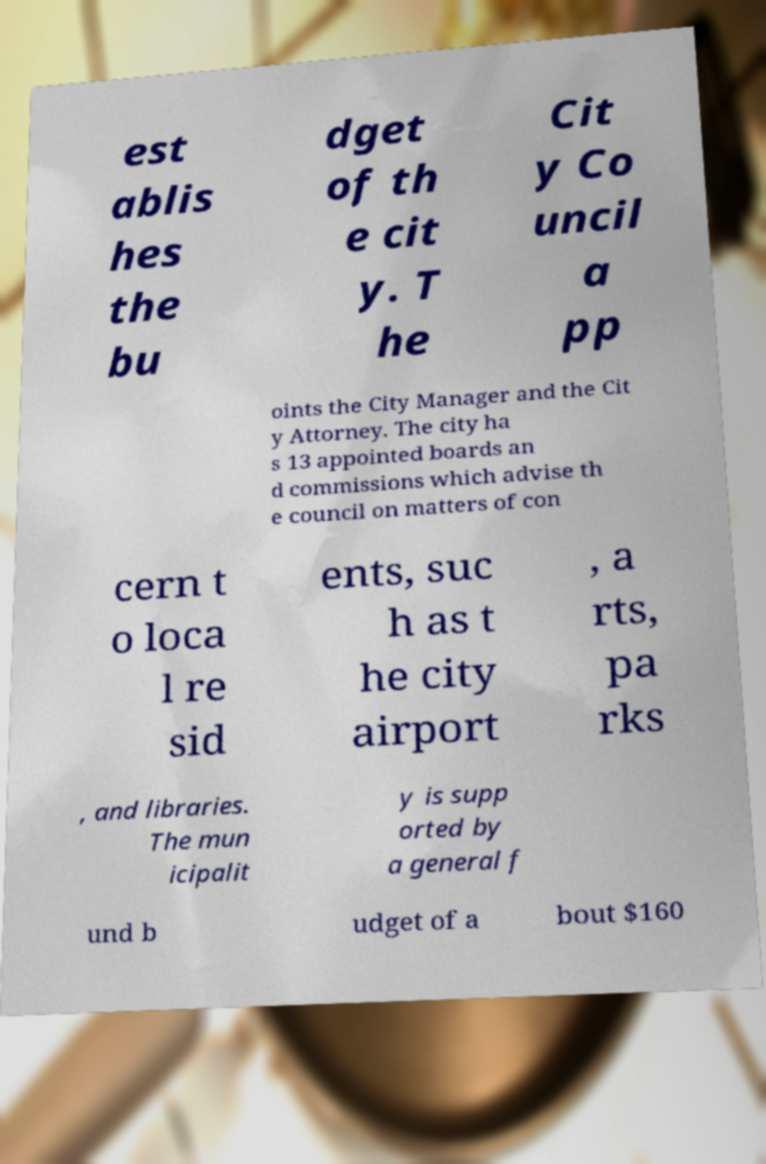I need the written content from this picture converted into text. Can you do that? est ablis hes the bu dget of th e cit y. T he Cit y Co uncil a pp oints the City Manager and the Cit y Attorney. The city ha s 13 appointed boards an d commissions which advise th e council on matters of con cern t o loca l re sid ents, suc h as t he city airport , a rts, pa rks , and libraries. The mun icipalit y is supp orted by a general f und b udget of a bout $160 